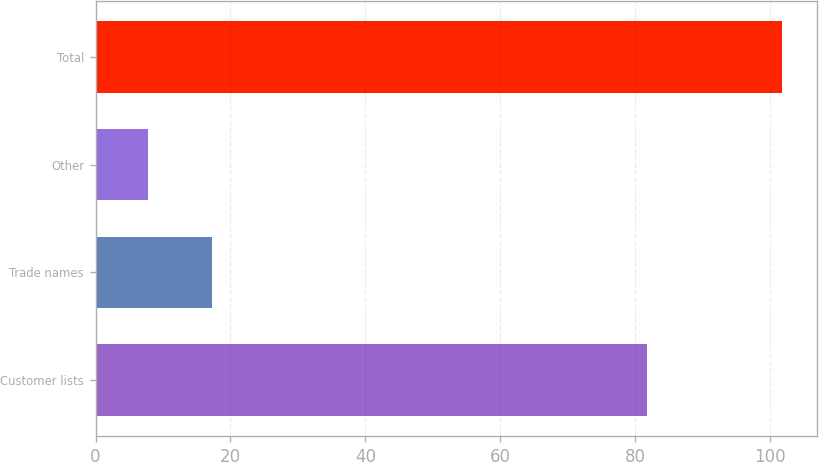Convert chart. <chart><loc_0><loc_0><loc_500><loc_500><bar_chart><fcel>Customer lists<fcel>Trade names<fcel>Other<fcel>Total<nl><fcel>81.7<fcel>17.2<fcel>7.8<fcel>101.8<nl></chart> 